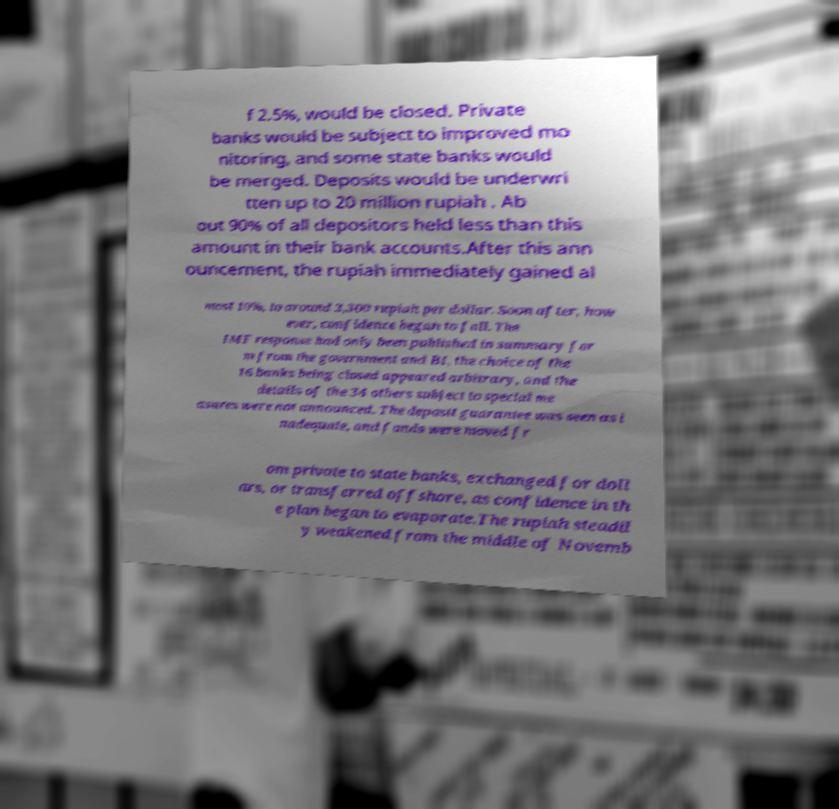Can you read and provide the text displayed in the image?This photo seems to have some interesting text. Can you extract and type it out for me? f 2.5%, would be closed. Private banks would be subject to improved mo nitoring, and some state banks would be merged. Deposits would be underwri tten up to 20 million rupiah . Ab out 90% of all depositors held less than this amount in their bank accounts.After this ann ouncement, the rupiah immediately gained al most 10%, to around 3,300 rupiah per dollar. Soon after, how ever, confidence began to fall. The IMF response had only been published in summary for m from the government and BI, the choice of the 16 banks being closed appeared arbitrary, and the details of the 34 others subject to special me asures were not announced. The deposit guarantee was seen as i nadequate, and funds were moved fr om private to state banks, exchanged for doll ars, or transferred offshore, as confidence in th e plan began to evaporate.The rupiah steadil y weakened from the middle of Novemb 